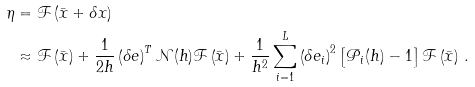Convert formula to latex. <formula><loc_0><loc_0><loc_500><loc_500>\eta & = \mathcal { F } \left ( \bar { x } + \delta x \right ) \\ & \approx \mathcal { F } \left ( \bar { x } \right ) + \frac { 1 } { 2 h } \left ( \delta e \right ) ^ { T } \mathcal { N } ( h ) \mathcal { F } \left ( \bar { x } \right ) + \frac { 1 } { h ^ { 2 } } \sum _ { i = 1 } ^ { L } \left ( \delta e _ { i } \right ) ^ { 2 } \left [ \mathcal { P } _ { i } ( h ) - 1 \right ] \mathcal { F } \left ( \bar { x } \right ) \, .</formula> 